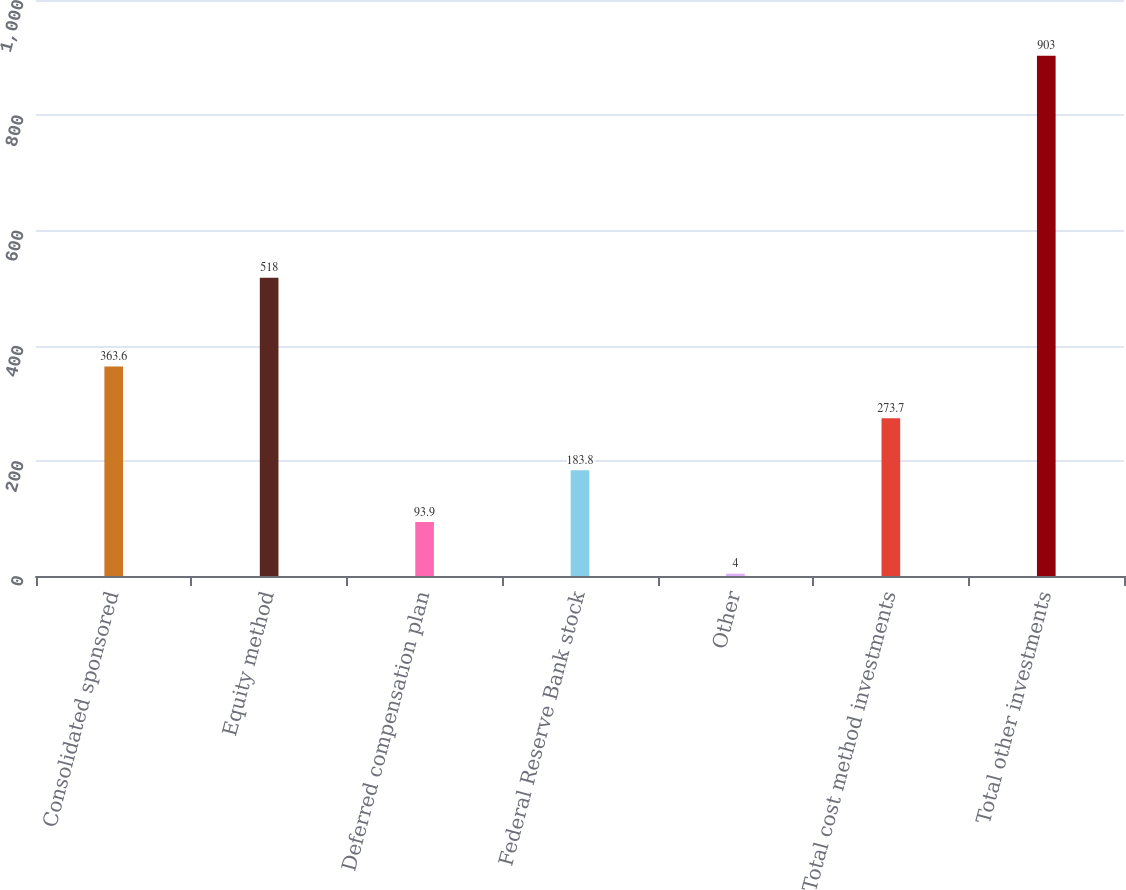Convert chart. <chart><loc_0><loc_0><loc_500><loc_500><bar_chart><fcel>Consolidated sponsored<fcel>Equity method<fcel>Deferred compensation plan<fcel>Federal Reserve Bank stock<fcel>Other<fcel>Total cost method investments<fcel>Total other investments<nl><fcel>363.6<fcel>518<fcel>93.9<fcel>183.8<fcel>4<fcel>273.7<fcel>903<nl></chart> 